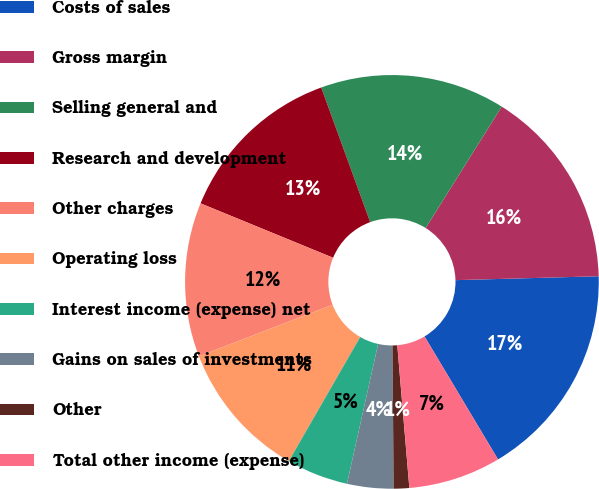Convert chart to OTSL. <chart><loc_0><loc_0><loc_500><loc_500><pie_chart><fcel>Costs of sales<fcel>Gross margin<fcel>Selling general and<fcel>Research and development<fcel>Other charges<fcel>Operating loss<fcel>Interest income (expense) net<fcel>Gains on sales of investments<fcel>Other<fcel>Total other income (expense)<nl><fcel>16.86%<fcel>15.66%<fcel>14.46%<fcel>13.25%<fcel>12.05%<fcel>10.84%<fcel>4.82%<fcel>3.62%<fcel>1.21%<fcel>7.23%<nl></chart> 